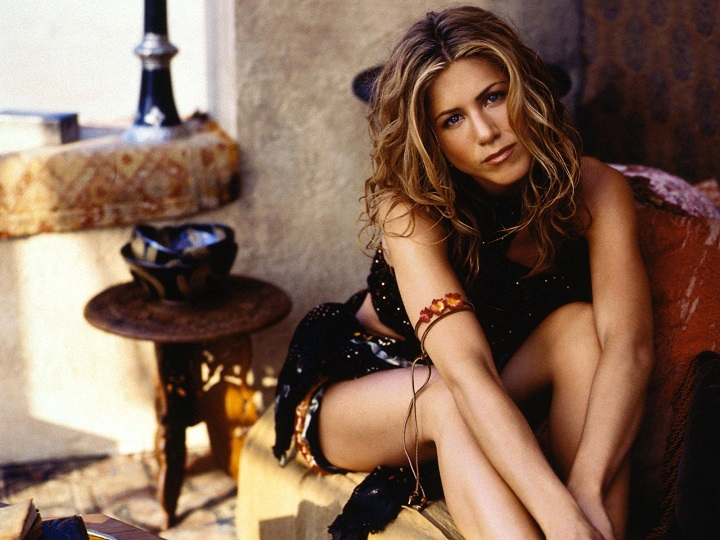Can you describe the design style of the room shown in the image? The room displayed in the image showcases a bohemian chic design style merged with rustic elements that are reminiscent of Mediterranean interiors. Features like the flowy, patterned garments, the use of rich textures and colors, and the casual seating arrangement, all model a bohemian lifestyle. This is complemented by rustic details like the wooden furniture and stucco walls, which ground the design in traditional aesthetics typical of Mediterranean homes. 